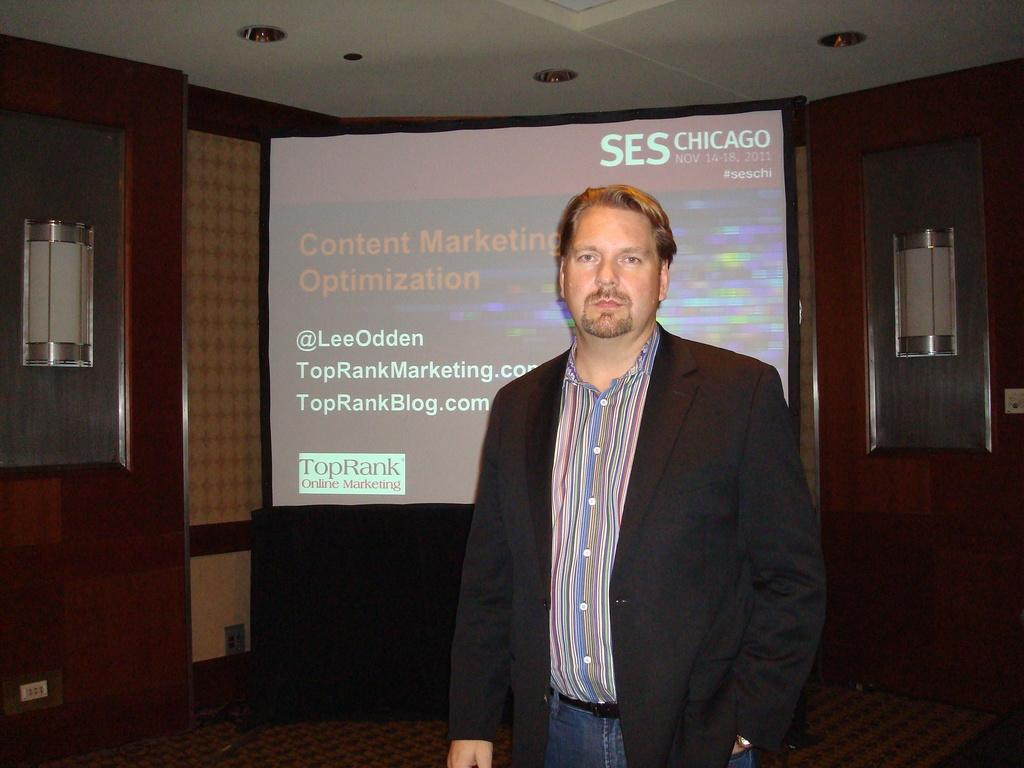What is the main subject in the image? There is a person in the image. What is located behind the person? There is a screen with text behind the person. What type of structure can be seen in the image? There is a wall in the image. What is above the person in the image? There is a ceiling in the image. What can be seen providing illumination in the image? There are lights visible in the image. Reasoning: Let'g: Let's think step by step in order to produce the conversation. We start by identifying the main subject in the image, which is the person. Then, we describe the background and surrounding elements, such as the screen with text, the wall, and the ceiling. Finally, we mention the lights that provide illumination in the image. Absurd Question/Answer: What type of mitten is the person wearing in the image? There is no mitten visible in the image; the person is not wearing any gloves or mittens. Can you tell me how many bats are flying in the image? There are no bats present in the image; it does not depict any animals or flying creatures. 